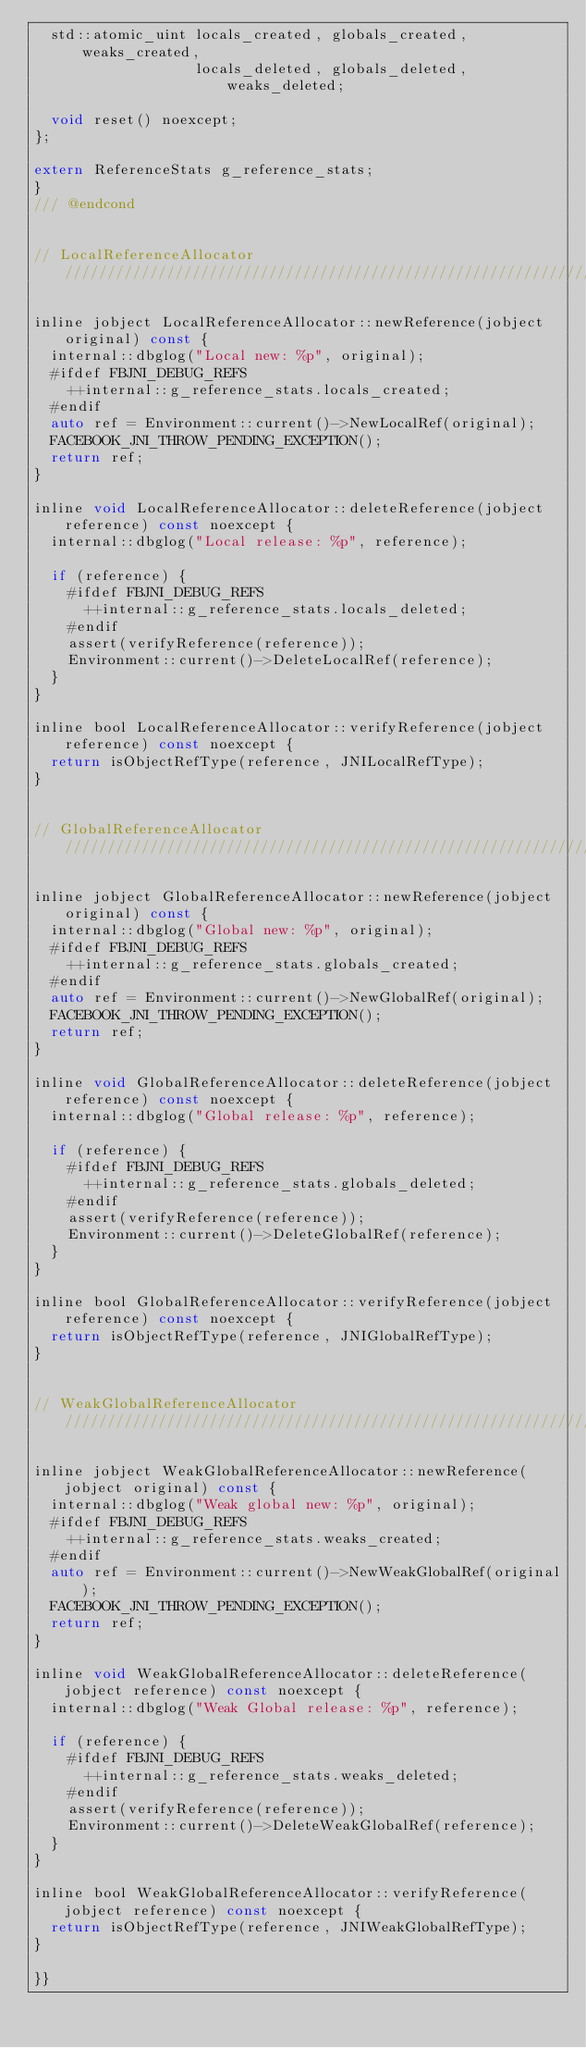<code> <loc_0><loc_0><loc_500><loc_500><_C_>  std::atomic_uint locals_created, globals_created, weaks_created,
                   locals_deleted, globals_deleted, weaks_deleted;

  void reset() noexcept;
};

extern ReferenceStats g_reference_stats;
}
/// @endcond


// LocalReferenceAllocator /////////////////////////////////////////////////////////////////////////

inline jobject LocalReferenceAllocator::newReference(jobject original) const {
  internal::dbglog("Local new: %p", original);
  #ifdef FBJNI_DEBUG_REFS
    ++internal::g_reference_stats.locals_created;
  #endif
  auto ref = Environment::current()->NewLocalRef(original);
  FACEBOOK_JNI_THROW_PENDING_EXCEPTION();
  return ref;
}

inline void LocalReferenceAllocator::deleteReference(jobject reference) const noexcept {
  internal::dbglog("Local release: %p", reference);

  if (reference) {
    #ifdef FBJNI_DEBUG_REFS
      ++internal::g_reference_stats.locals_deleted;
    #endif
    assert(verifyReference(reference));
    Environment::current()->DeleteLocalRef(reference);
  }
}

inline bool LocalReferenceAllocator::verifyReference(jobject reference) const noexcept {
  return isObjectRefType(reference, JNILocalRefType);
}


// GlobalReferenceAllocator ////////////////////////////////////////////////////////////////////////

inline jobject GlobalReferenceAllocator::newReference(jobject original) const {
  internal::dbglog("Global new: %p", original);
  #ifdef FBJNI_DEBUG_REFS
    ++internal::g_reference_stats.globals_created;
  #endif
  auto ref = Environment::current()->NewGlobalRef(original);
  FACEBOOK_JNI_THROW_PENDING_EXCEPTION();
  return ref;
}

inline void GlobalReferenceAllocator::deleteReference(jobject reference) const noexcept {
  internal::dbglog("Global release: %p", reference);

  if (reference) {
    #ifdef FBJNI_DEBUG_REFS
      ++internal::g_reference_stats.globals_deleted;
    #endif
    assert(verifyReference(reference));
    Environment::current()->DeleteGlobalRef(reference);
  }
}

inline bool GlobalReferenceAllocator::verifyReference(jobject reference) const noexcept {
  return isObjectRefType(reference, JNIGlobalRefType);
}


// WeakGlobalReferenceAllocator ////////////////////////////////////////////////////////////////////

inline jobject WeakGlobalReferenceAllocator::newReference(jobject original) const {
  internal::dbglog("Weak global new: %p", original);
  #ifdef FBJNI_DEBUG_REFS
    ++internal::g_reference_stats.weaks_created;
  #endif
  auto ref = Environment::current()->NewWeakGlobalRef(original);
  FACEBOOK_JNI_THROW_PENDING_EXCEPTION();
  return ref;
}

inline void WeakGlobalReferenceAllocator::deleteReference(jobject reference) const noexcept {
  internal::dbglog("Weak Global release: %p", reference);

  if (reference) {
    #ifdef FBJNI_DEBUG_REFS
      ++internal::g_reference_stats.weaks_deleted;
    #endif
    assert(verifyReference(reference));
    Environment::current()->DeleteWeakGlobalRef(reference);
  }
}

inline bool WeakGlobalReferenceAllocator::verifyReference(jobject reference) const noexcept {
  return isObjectRefType(reference, JNIWeakGlobalRefType);
}

}}
</code> 